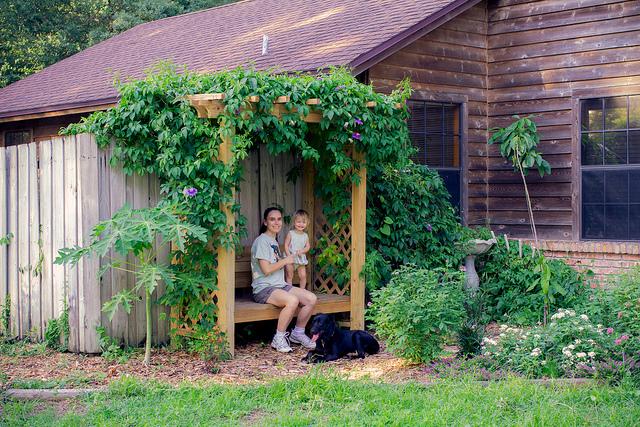How many children are in the picture?
Short answer required. 1. What is the dog doing?
Quick response, please. Laying down. What color are the girl's shorts?
Short answer required. Gray. 